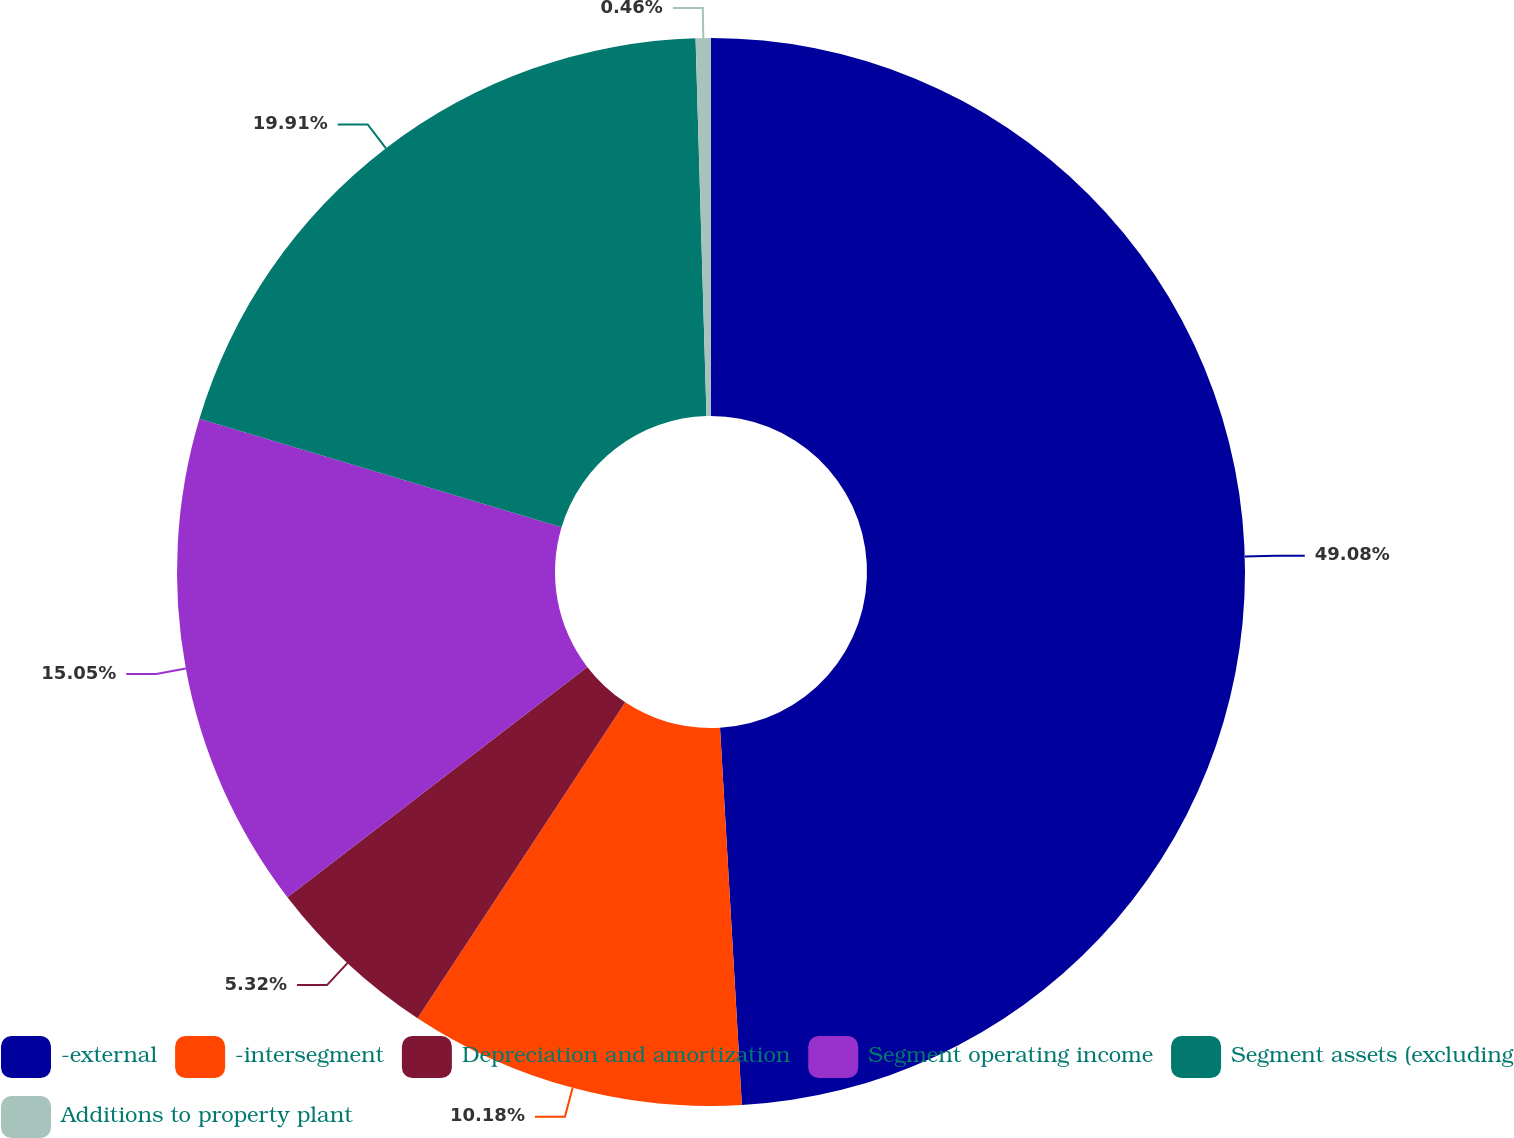Convert chart. <chart><loc_0><loc_0><loc_500><loc_500><pie_chart><fcel>-external<fcel>-intersegment<fcel>Depreciation and amortization<fcel>Segment operating income<fcel>Segment assets (excluding<fcel>Additions to property plant<nl><fcel>49.08%<fcel>10.18%<fcel>5.32%<fcel>15.05%<fcel>19.91%<fcel>0.46%<nl></chart> 